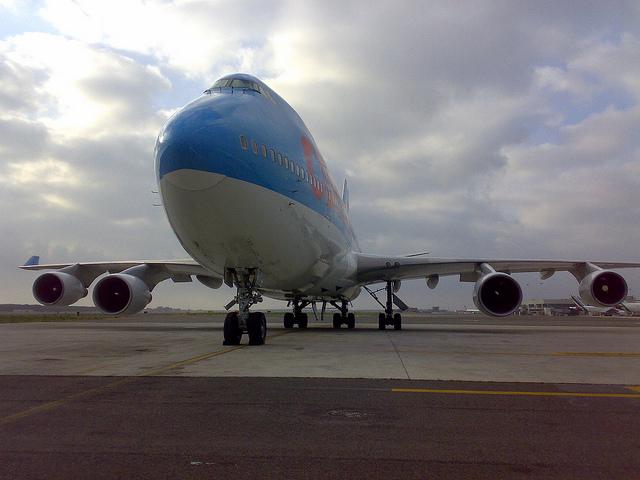Is this a commercial plane?
Be succinct. Yes. How many engines are shown?
Keep it brief. 4. Is this plane ready for takeoff?
Answer briefly. Yes. Is the plane being refueled right now?
Quick response, please. No. What is happening to the plane?
Quick response, please. Landing. What color stripe is on this plane?
Quick response, please. Blue. 